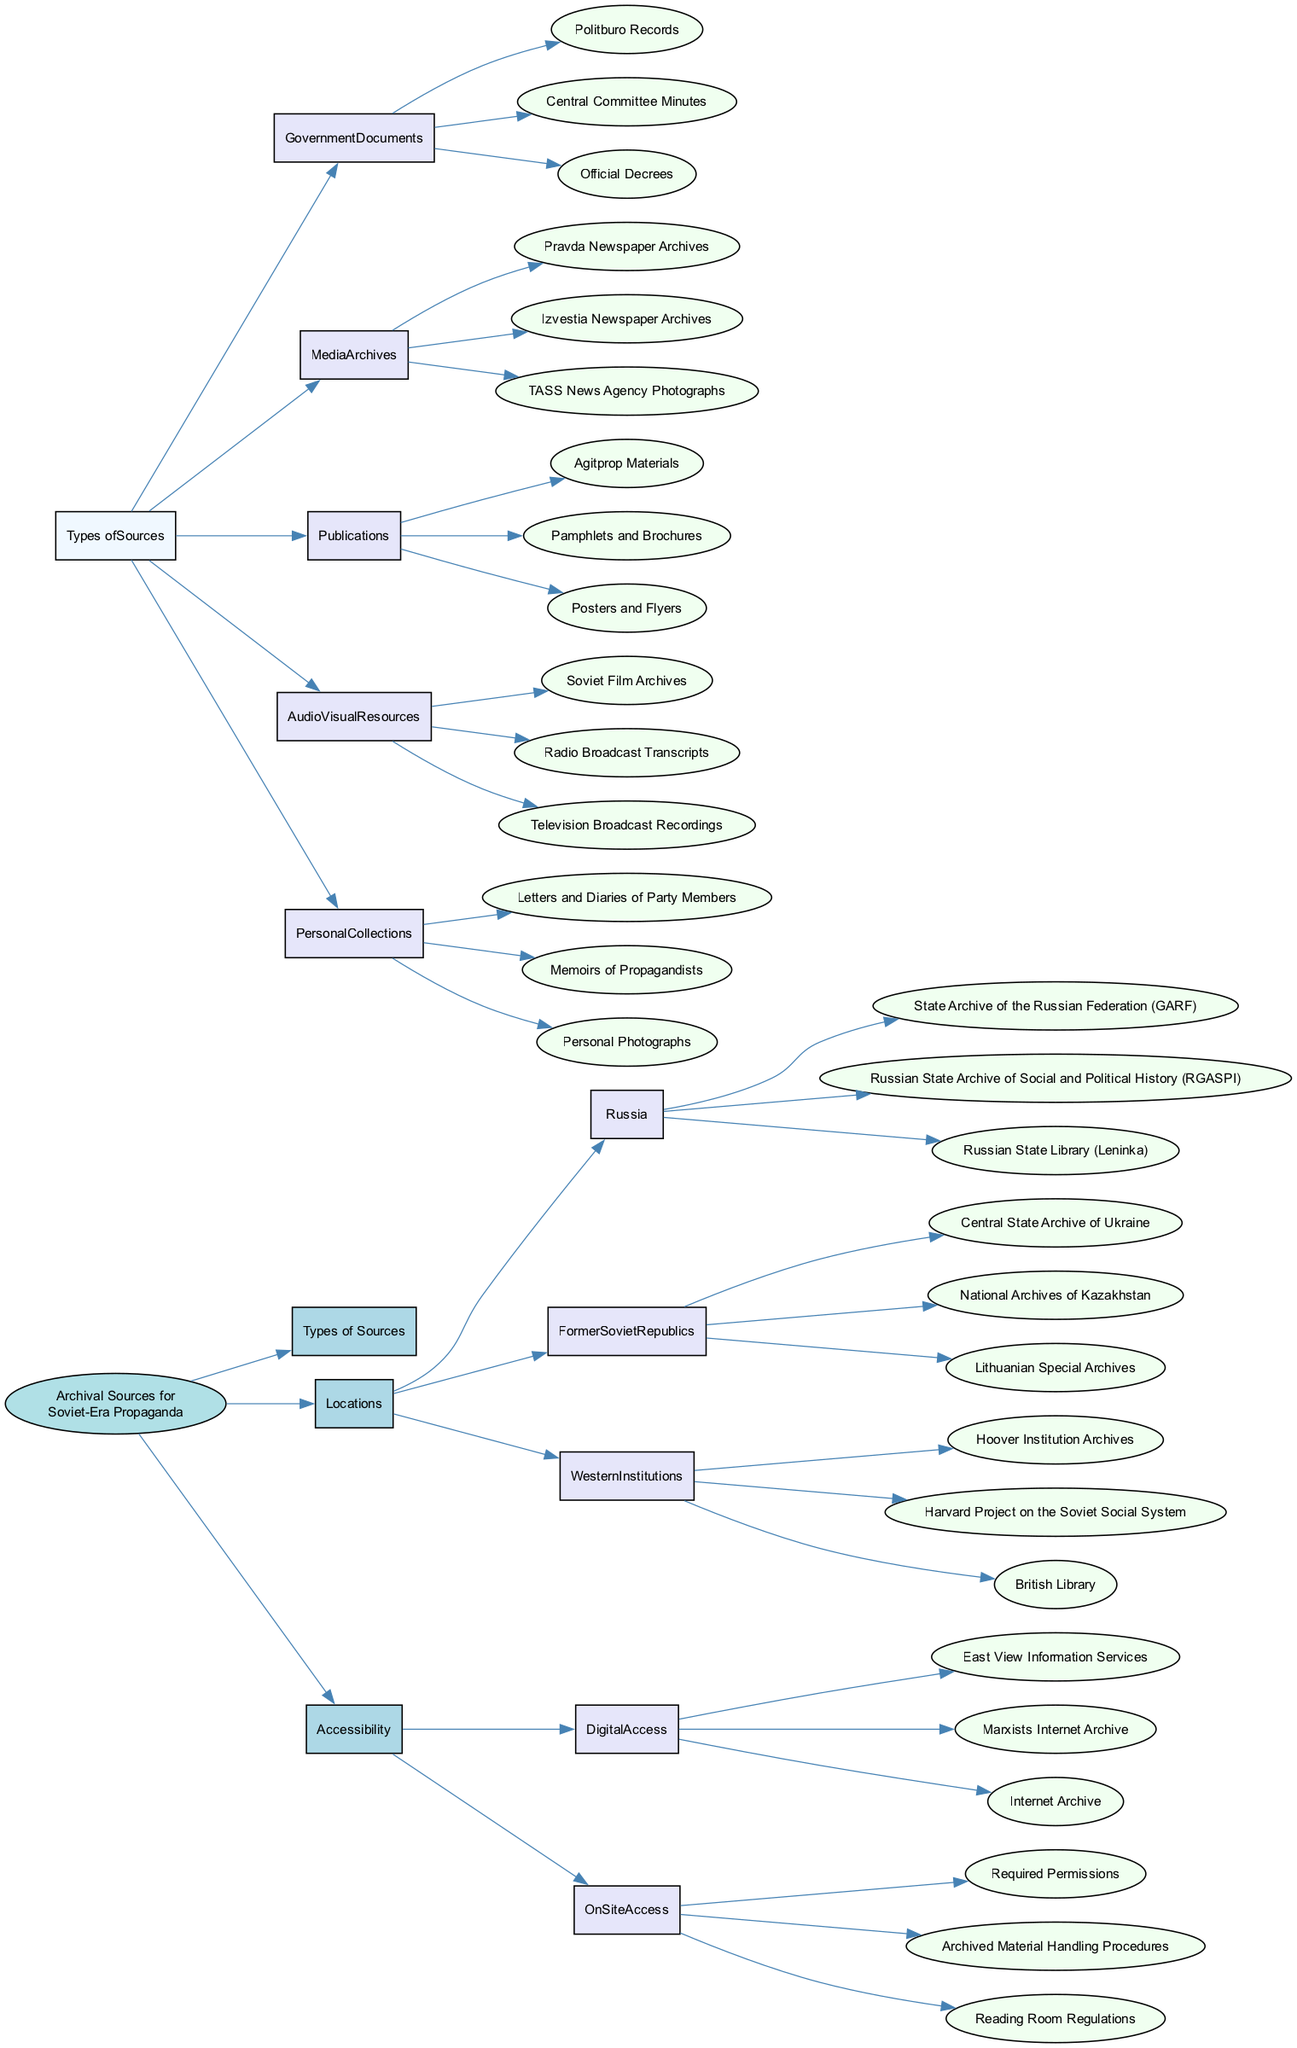What are the three main categories of archival sources? The diagram shows three main categories: Types of Sources, Locations, and Accessibility. These categories are directly connected to the main node, indicating they are the primary divisions of information.
Answer: Types of Sources, Locations, Accessibility How many types of sources are listed under "Types of Sources"? Under "Types of Sources," there are five subcategories: Government Documents, Media Archives, Publications, Audio Visual Resources, and Personal Collections. Counting these subcategories gives a total of five.
Answer: 5 Which archive is located in Russia? The diagram lists three specific archives in Russia, including the State Archive of the Russian Federation, Russian State Archive of Social and Political History, and Russian State Library. Any of these could be correct, as they are all included under the Russian location.
Answer: State Archive of the Russian Federation What are the three examples of audiovisual resources? The diagram shows three items listed under Audio Visual Resources: Soviet Film Archives, Radio Broadcast Transcripts, and Television Broadcast Recordings. These items specifically detail the audiovisual aspects of archival sources.
Answer: Soviet Film Archives, Radio Broadcast Transcripts, Television Broadcast Recordings What accessibility type requires permissions? The diagram indicates that On-Site Access requires certain protocols, specifically mentioning Required Permissions. This directly links the concept of accessibility with a requirement for being physically on-site to access materials.
Answer: Required Permissions Which western institution is noted for its archives? The diagram lists three archives from Western institutions; one example is the Hoover Institution Archives. This institution is a specific point of reference for researchers looking at Soviet-era propaganda materials outside Russia.
Answer: Hoover Institution Archives Can you name a digital access service mentioned in the diagram? The diagram provides several examples of digital access services, one of which is the East View Information Services, directly linked under the Digital Access category. This shows that it’s a recognized service for online access to archival sources.
Answer: East View Information Services What is the first item listed under "Personal Collections"? The diagram shows that the first item listed under Personal Collections is "Letters and Diaries of Party Members." This indicates the personal historical context provided by individuals involved in the propaganda efforts.
Answer: Letters and Diaries of Party Members Which subcategory has the highest number of items? To determine which subcategory has the highest number of items, we can examine the lists: "Types of Sources" includes five, "Locations" includes three under each region, and "Accessibility" has two types. Therefore, the highest number is found in "Types of Sources."
Answer: Types of Sources 